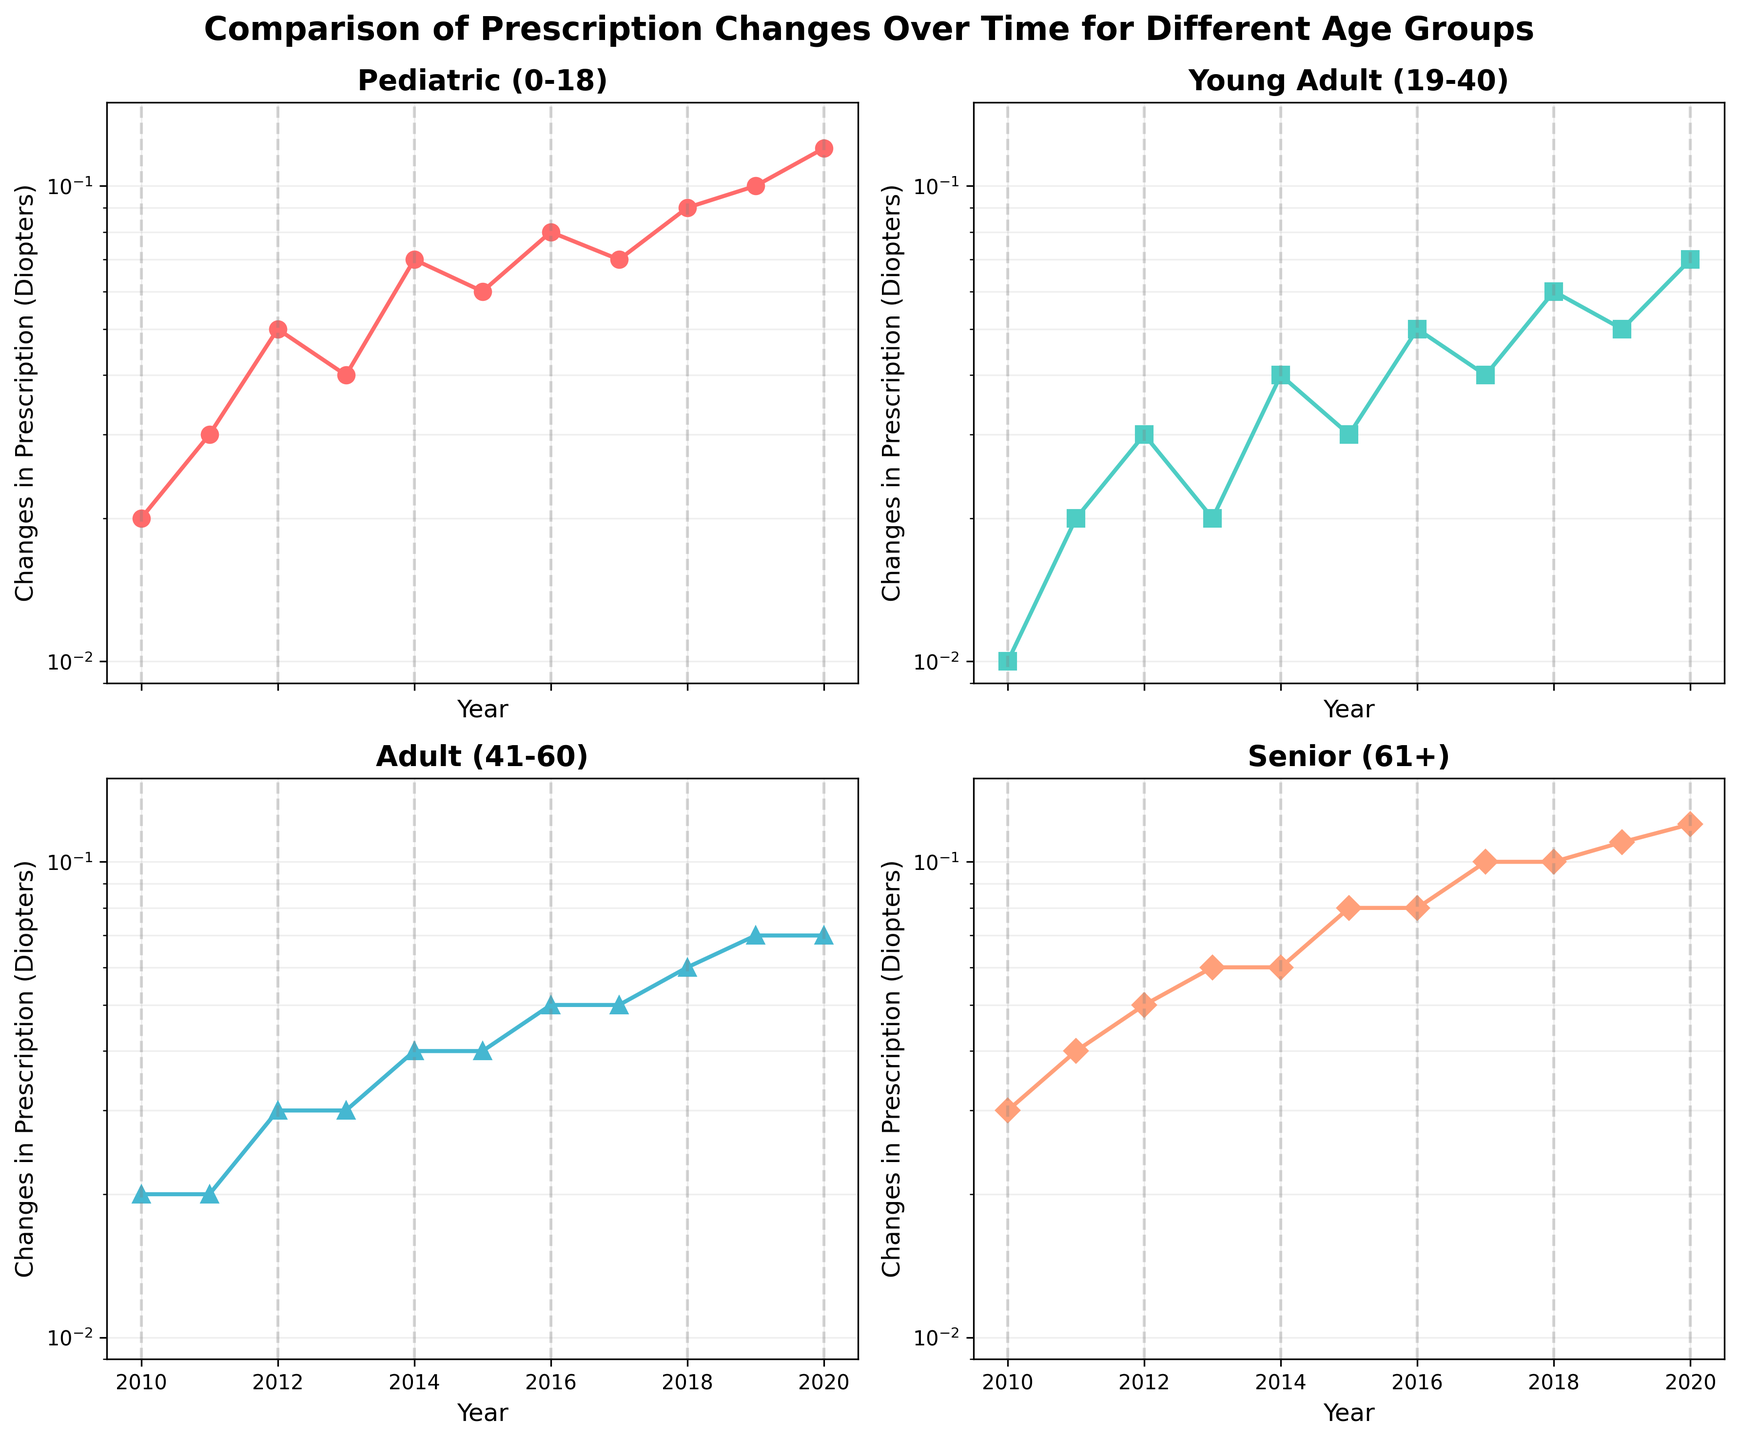What is the title of this figure? The title of the figure is usually located at the top center. In this case, the title reads, "Comparison of Prescription Changes Over Time for Different Age Groups".
Answer: Comparison of Prescription Changes Over Time for Different Age Groups In which year did the Pediatric age group experience a change in prescription of 0.1 Diopters? Look at the subplot for the Pediatric (0-18) age group and identify the year corresponding to 0.1 Diopters. This occurs at the point labeled 2019.
Answer: 2019 Which age group shows the highest change in prescription in 2020? By examining the y-axis for each subplot at the year 2020, we see that the highest change in prescription in 2020 occurs for the Senior (61+) age group, which is 0.12 Diopters.
Answer: Senior (61+) Compare the changes in prescription for the Young Adult group from 2010 to 2012. What is the increase? From the Young Adult (19-40) subplot, note the change in prescription for 2010 (0.01) and 2012 (0.03). The increase is found by subtracting the 2010 value from the 2012 value: 0.03 - 0.01 = 0.02 Diopters.
Answer: 0.02 Diopters Which age group had the lowest change in prescription in 2010 and what was the value? Looking at all subplots for the year 2010, the lowest change in prescription is for the Young Adult (19-40) age group with a change of 0.01 Diopters.
Answer: Young Adult (19-40), 0.01 Diopters What is the range of change in prescriptions for the Pediatric group over the years? The range in any dataset is the difference between the maximum and minimum values. For the Pediatric (0-18) group, the minimum change is 0.02 Diopters (2010) and the maximum is 0.12 Diopters (2020). The range is 0.12 - 0.02 = 0.10 Diopters.
Answer: 0.10 Diopters Which age group shows the smallest variation in prescription changes over the observed years? By observing the fluctuation in values within each subplot, the Adult (41-60) age group shows the smallest variation in prescription changes over the years, with changes ranging between 0.02 to 0.07 Diopters.
Answer: Adult (41-60) In which year did both the Adult and Senior groups have the same change in prescription of 0.04 Diopters? Inspect the subplots for both the Adult and Senior age groups. Identify 2014 as the year when both groups have a change in prescription of 0.04 Diopters.
Answer: 2014 How do change in prescriptions for the Senior group from 2010 to 2020 compare to the Pediatric group over the same period? For the Senior group, the change in prescription increased from 0.03 Diopters in 2010 to 0.12 in 2020. For the Pediatric group, the change went from 0.02 Diopters in 2010 to 0.12 in 2020. Both groups end up with the same value in 2020, but the Pediatric group's increase starts from a slightly lower base.
Answer: Both ended at 0.12 Diopters, Pediatric started lower 